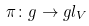Convert formula to latex. <formula><loc_0><loc_0><loc_500><loc_500>\pi \colon g \rightarrow g l _ { V }</formula> 